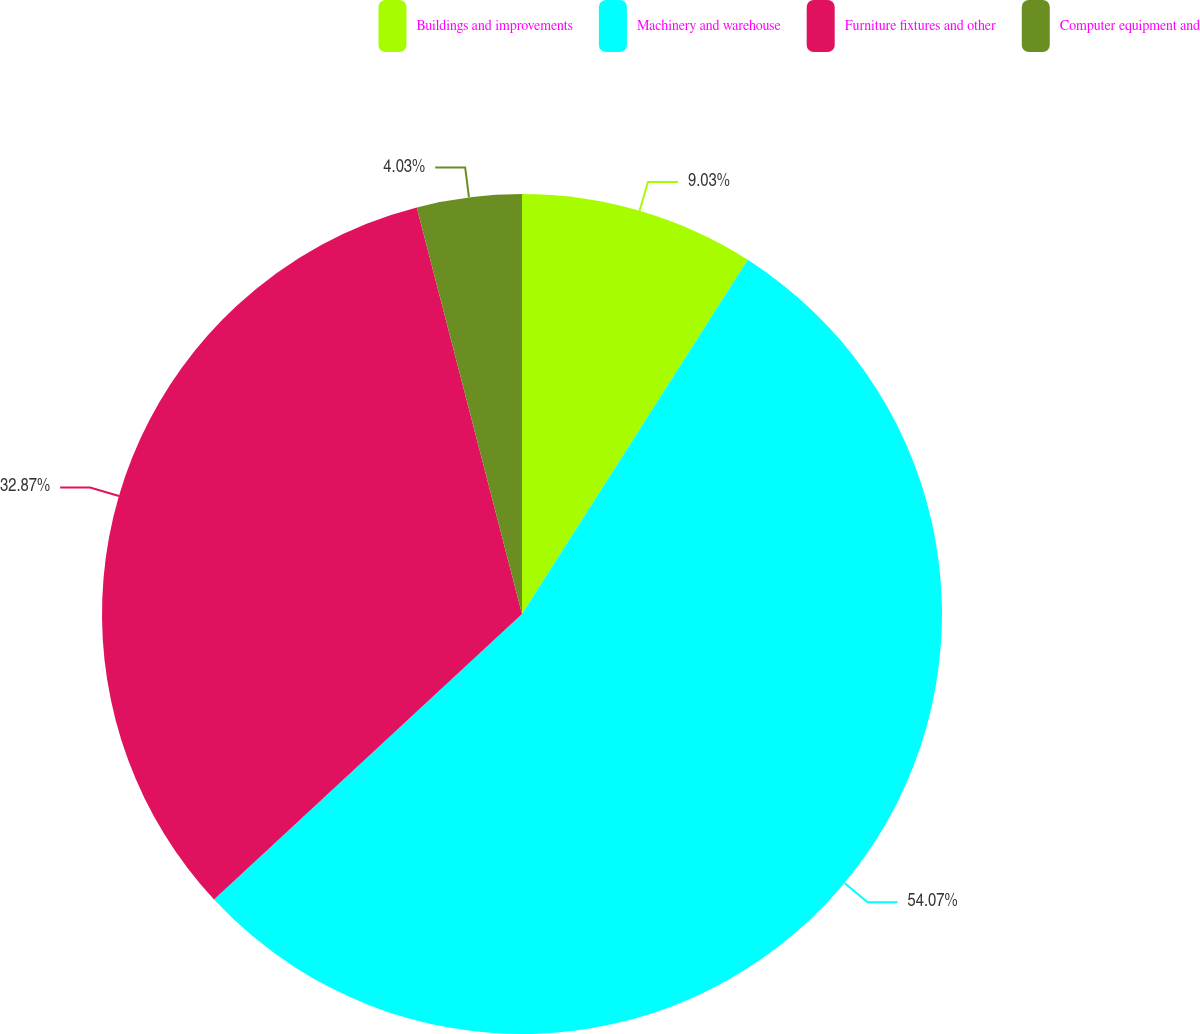Convert chart. <chart><loc_0><loc_0><loc_500><loc_500><pie_chart><fcel>Buildings and improvements<fcel>Machinery and warehouse<fcel>Furniture fixtures and other<fcel>Computer equipment and<nl><fcel>9.03%<fcel>54.07%<fcel>32.87%<fcel>4.03%<nl></chart> 